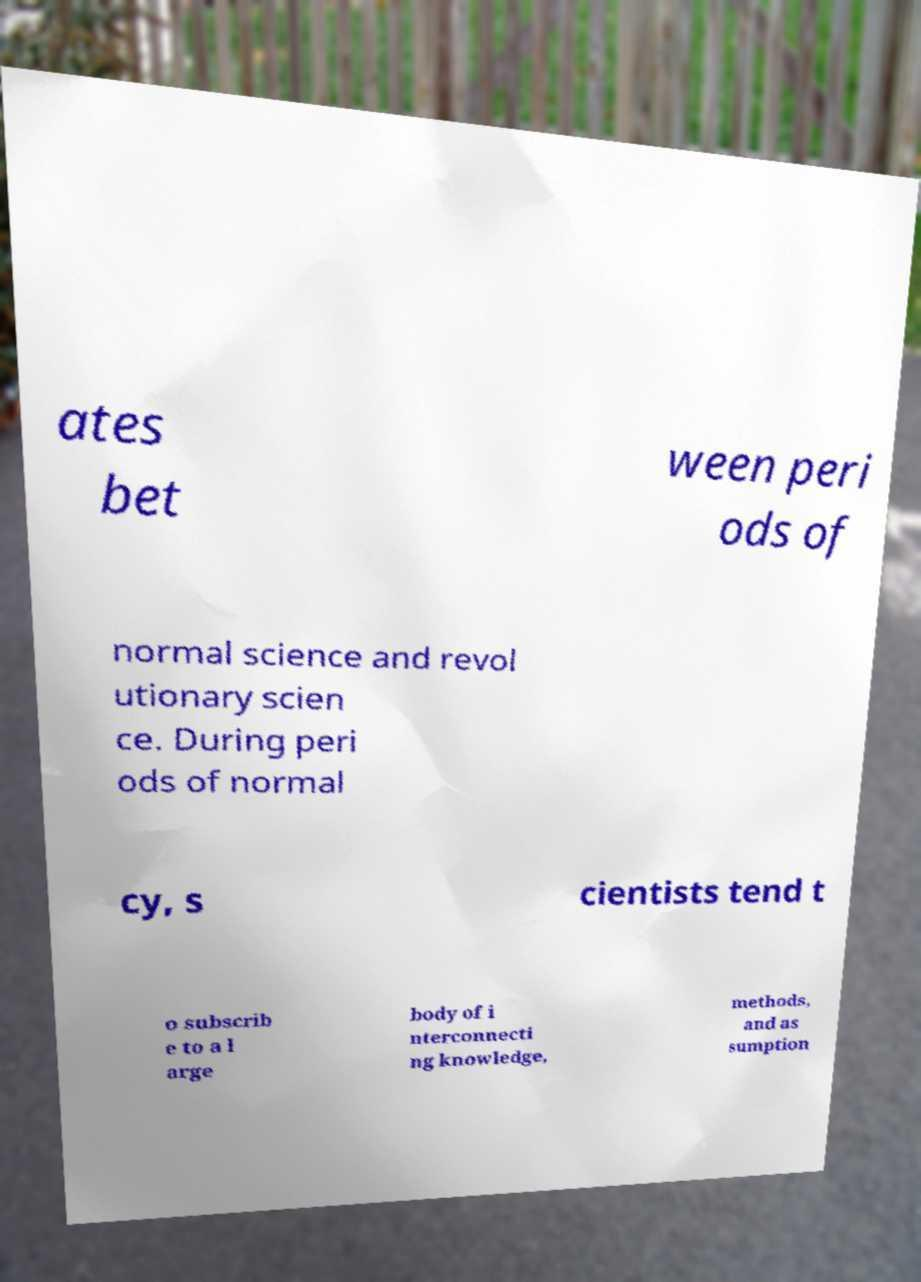Can you read and provide the text displayed in the image?This photo seems to have some interesting text. Can you extract and type it out for me? ates bet ween peri ods of normal science and revol utionary scien ce. During peri ods of normal cy, s cientists tend t o subscrib e to a l arge body of i nterconnecti ng knowledge, methods, and as sumption 